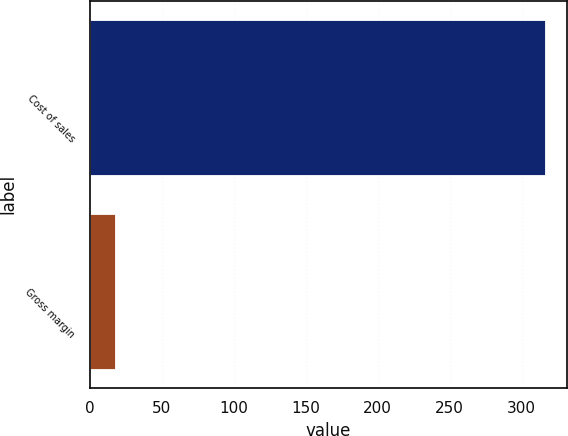Convert chart to OTSL. <chart><loc_0><loc_0><loc_500><loc_500><bar_chart><fcel>Cost of sales<fcel>Gross margin<nl><fcel>316<fcel>18<nl></chart> 